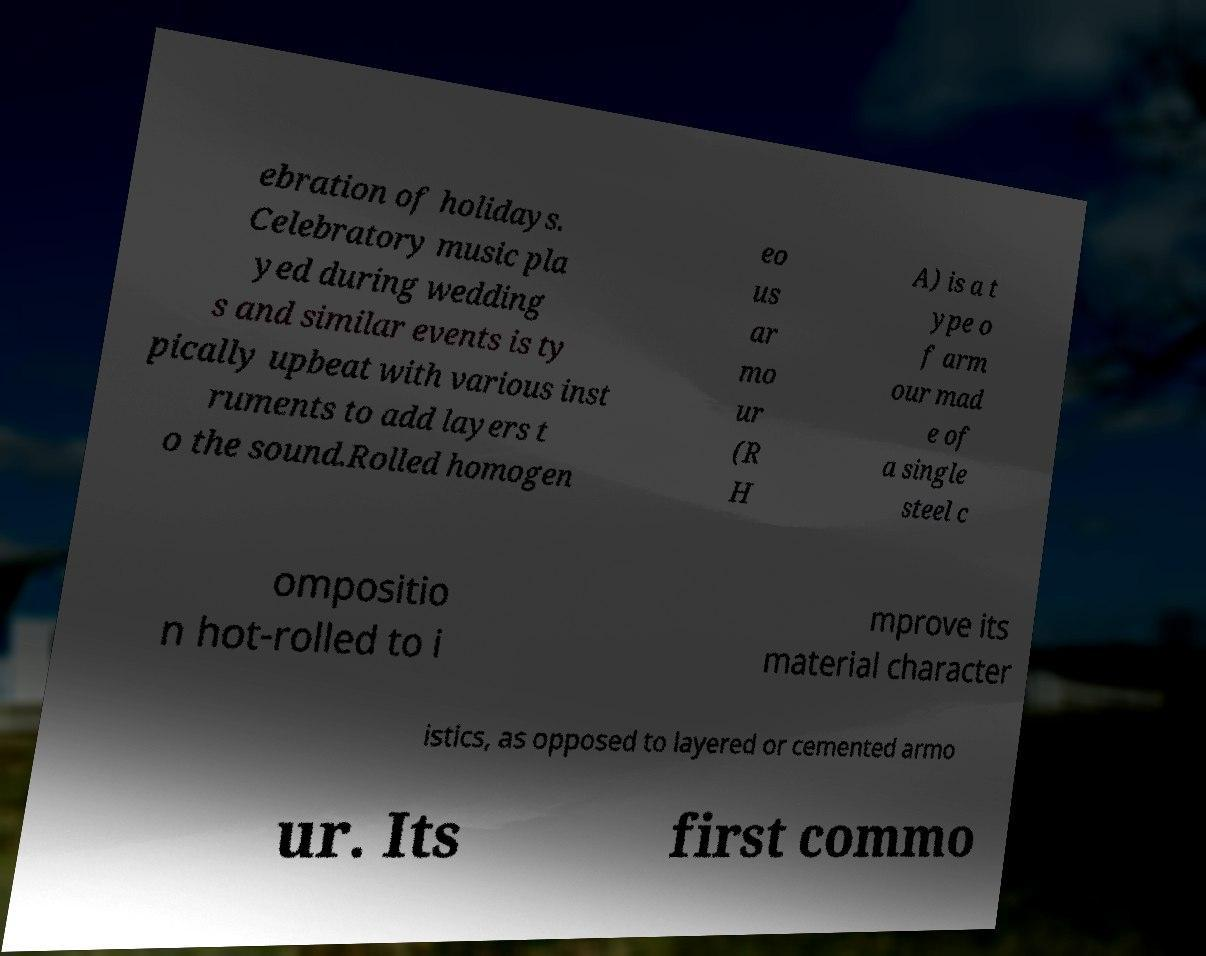Could you assist in decoding the text presented in this image and type it out clearly? ebration of holidays. Celebratory music pla yed during wedding s and similar events is ty pically upbeat with various inst ruments to add layers t o the sound.Rolled homogen eo us ar mo ur (R H A) is a t ype o f arm our mad e of a single steel c ompositio n hot-rolled to i mprove its material character istics, as opposed to layered or cemented armo ur. Its first commo 